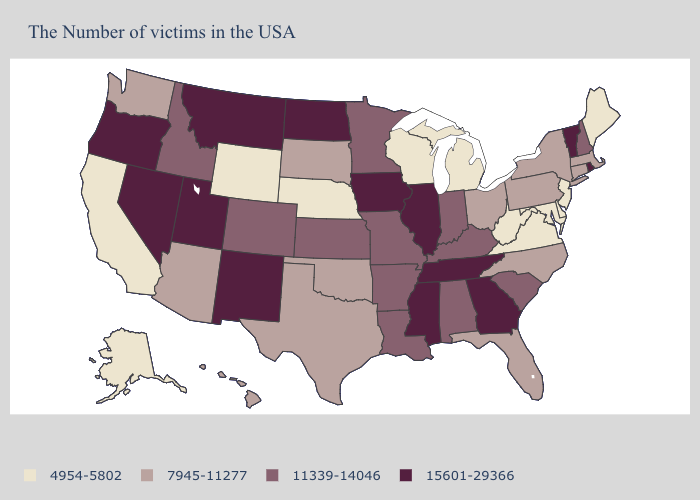Name the states that have a value in the range 11339-14046?
Be succinct. New Hampshire, South Carolina, Kentucky, Indiana, Alabama, Louisiana, Missouri, Arkansas, Minnesota, Kansas, Colorado, Idaho. What is the highest value in states that border Minnesota?
Give a very brief answer. 15601-29366. Does the first symbol in the legend represent the smallest category?
Quick response, please. Yes. What is the value of Virginia?
Write a very short answer. 4954-5802. What is the value of Tennessee?
Be succinct. 15601-29366. What is the value of Maine?
Be succinct. 4954-5802. Does Delaware have the highest value in the USA?
Give a very brief answer. No. Name the states that have a value in the range 11339-14046?
Concise answer only. New Hampshire, South Carolina, Kentucky, Indiana, Alabama, Louisiana, Missouri, Arkansas, Minnesota, Kansas, Colorado, Idaho. Does Oklahoma have the same value as Washington?
Give a very brief answer. Yes. Does Massachusetts have a lower value than Pennsylvania?
Give a very brief answer. No. Which states have the lowest value in the USA?
Write a very short answer. Maine, New Jersey, Delaware, Maryland, Virginia, West Virginia, Michigan, Wisconsin, Nebraska, Wyoming, California, Alaska. Name the states that have a value in the range 15601-29366?
Short answer required. Rhode Island, Vermont, Georgia, Tennessee, Illinois, Mississippi, Iowa, North Dakota, New Mexico, Utah, Montana, Nevada, Oregon. Which states have the lowest value in the South?
Short answer required. Delaware, Maryland, Virginia, West Virginia. Among the states that border South Carolina , which have the highest value?
Write a very short answer. Georgia. What is the value of Illinois?
Keep it brief. 15601-29366. 